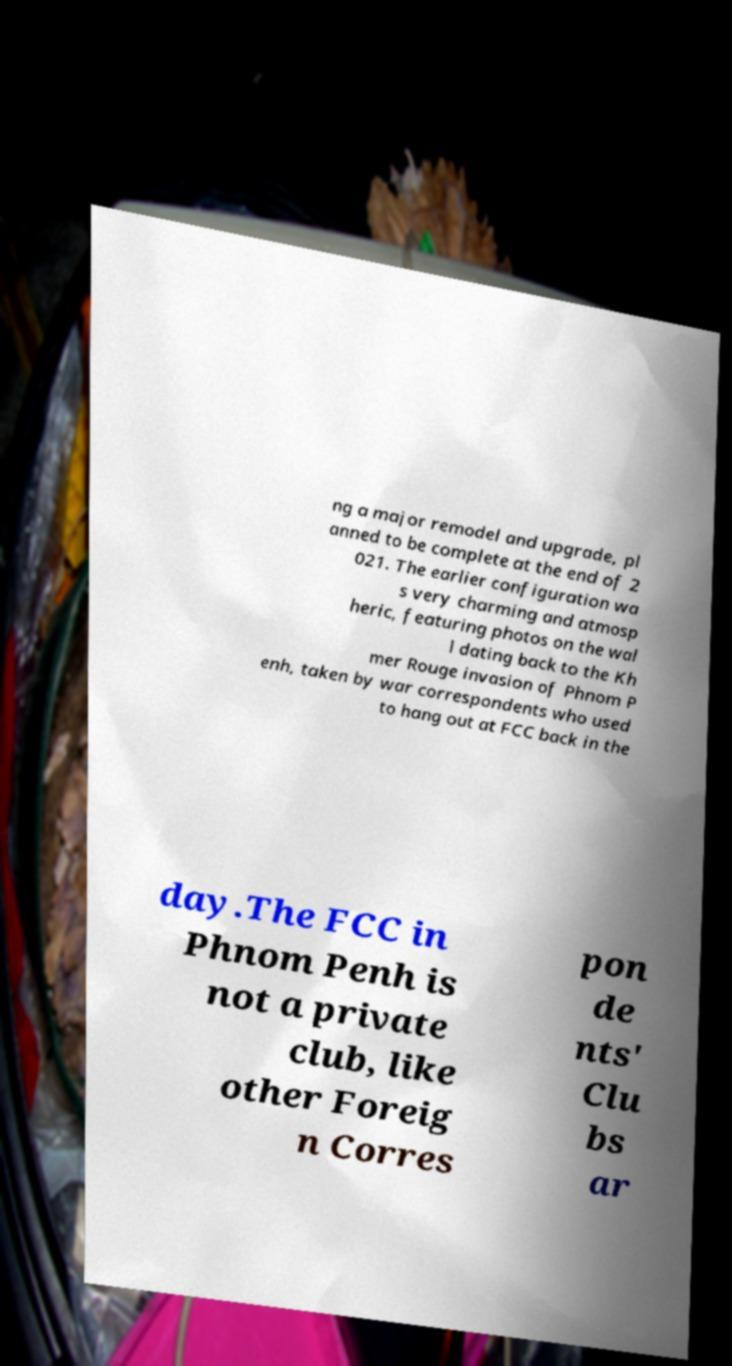Could you assist in decoding the text presented in this image and type it out clearly? ng a major remodel and upgrade, pl anned to be complete at the end of 2 021. The earlier configuration wa s very charming and atmosp heric, featuring photos on the wal l dating back to the Kh mer Rouge invasion of Phnom P enh, taken by war correspondents who used to hang out at FCC back in the day.The FCC in Phnom Penh is not a private club, like other Foreig n Corres pon de nts' Clu bs ar 